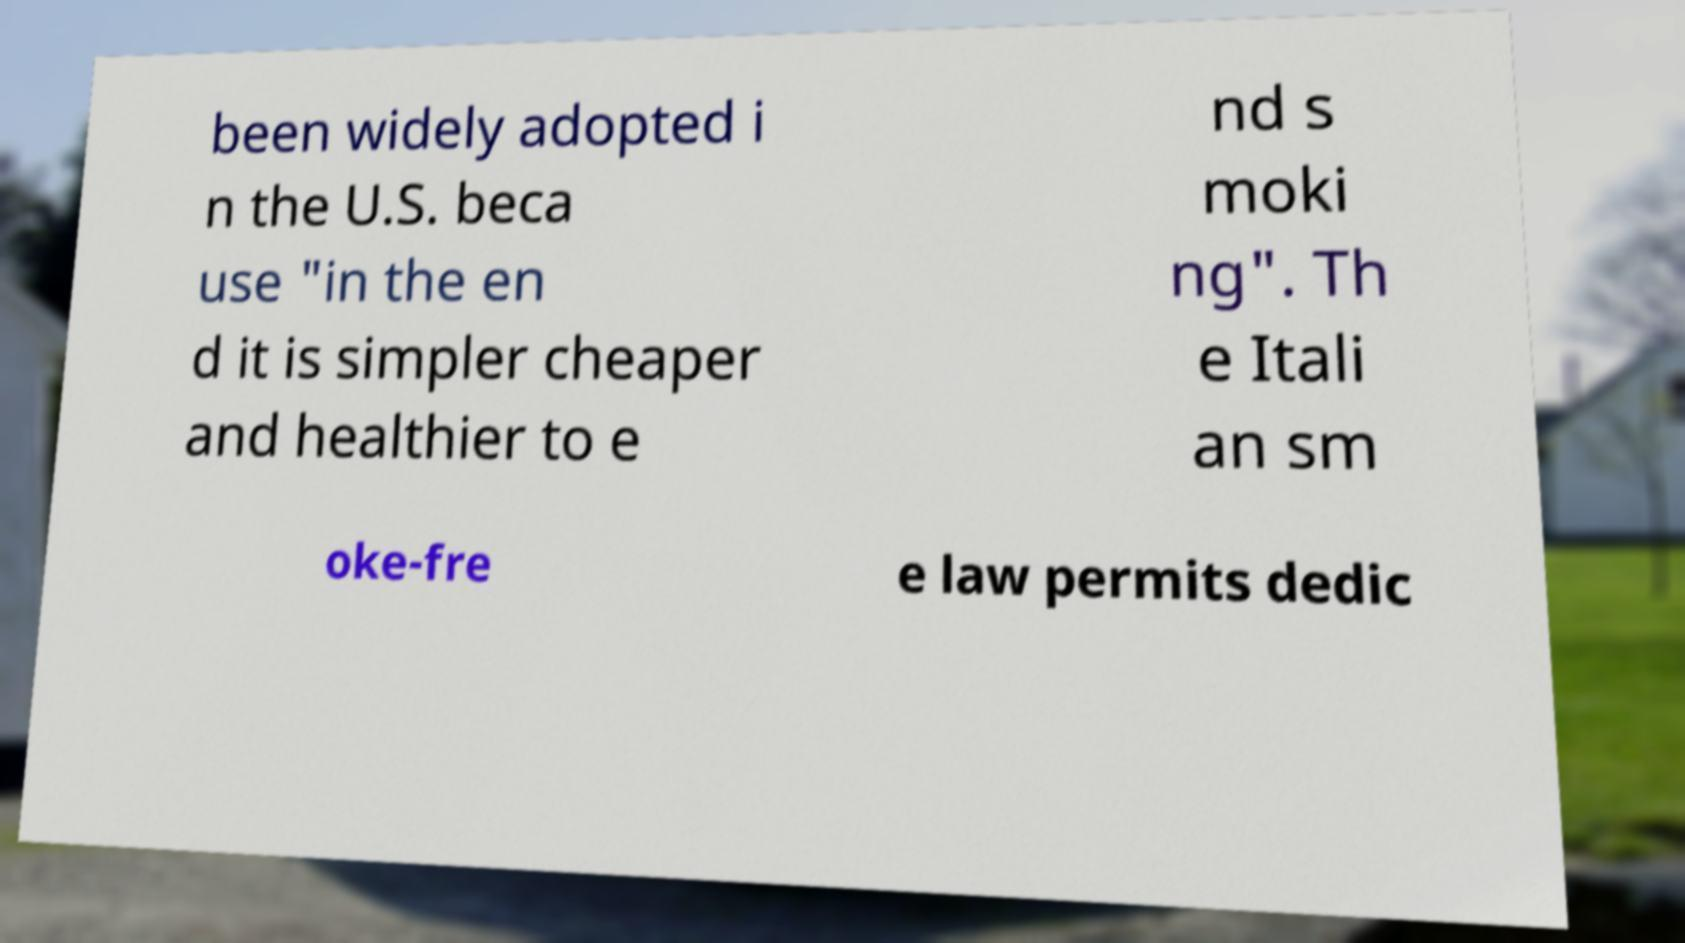I need the written content from this picture converted into text. Can you do that? been widely adopted i n the U.S. beca use "in the en d it is simpler cheaper and healthier to e nd s moki ng". Th e Itali an sm oke-fre e law permits dedic 